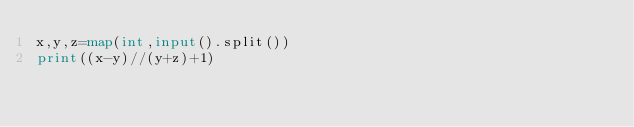Convert code to text. <code><loc_0><loc_0><loc_500><loc_500><_Python_>x,y,z=map(int,input().split())
print((x-y)//(y+z)+1)</code> 